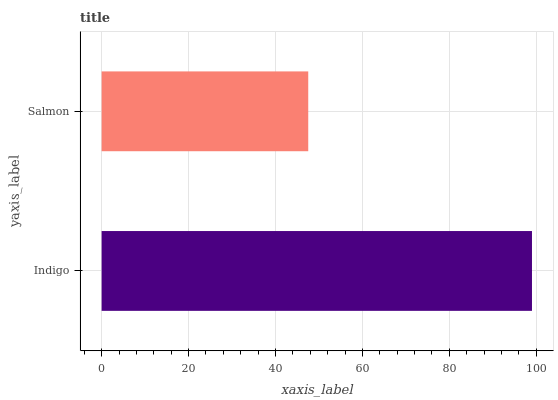Is Salmon the minimum?
Answer yes or no. Yes. Is Indigo the maximum?
Answer yes or no. Yes. Is Salmon the maximum?
Answer yes or no. No. Is Indigo greater than Salmon?
Answer yes or no. Yes. Is Salmon less than Indigo?
Answer yes or no. Yes. Is Salmon greater than Indigo?
Answer yes or no. No. Is Indigo less than Salmon?
Answer yes or no. No. Is Indigo the high median?
Answer yes or no. Yes. Is Salmon the low median?
Answer yes or no. Yes. Is Salmon the high median?
Answer yes or no. No. Is Indigo the low median?
Answer yes or no. No. 